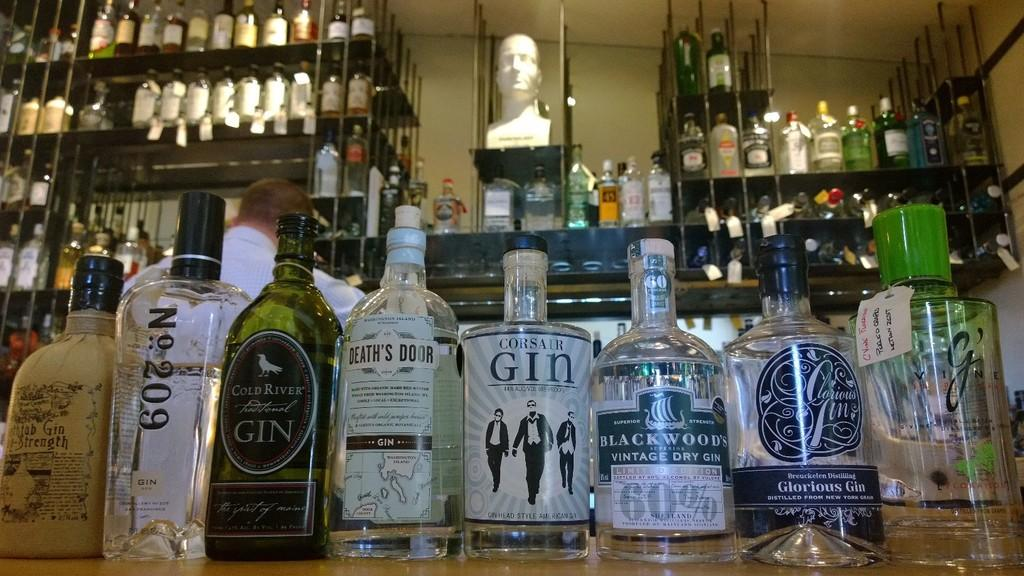Provide a one-sentence caption for the provided image. Large assortment of primarily gin alcohol on shelves and racks. 